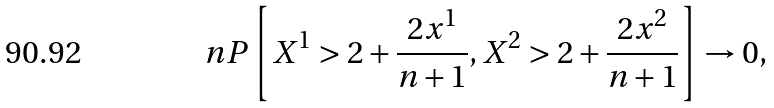Convert formula to latex. <formula><loc_0><loc_0><loc_500><loc_500>n P \left [ X ^ { 1 } > 2 + \frac { 2 x ^ { 1 } } { n + 1 } , X ^ { 2 } > 2 + \frac { 2 x ^ { 2 } } { n + 1 } \right ] \rightarrow 0 ,</formula> 